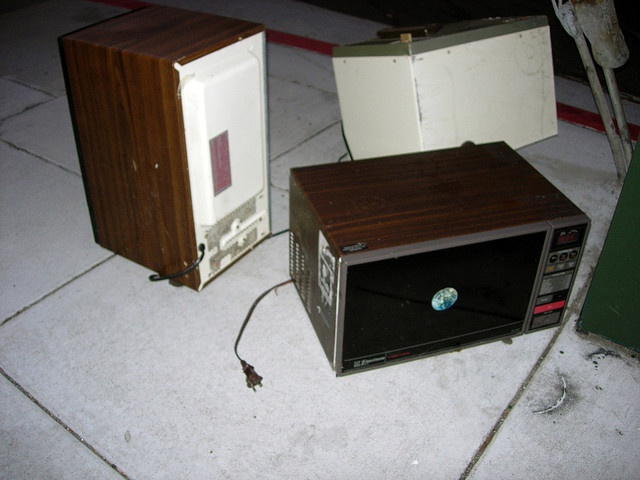Describe the objects in this image and their specific colors. I can see microwave in black and gray tones and microwave in black, darkgray, and lightgray tones in this image. 